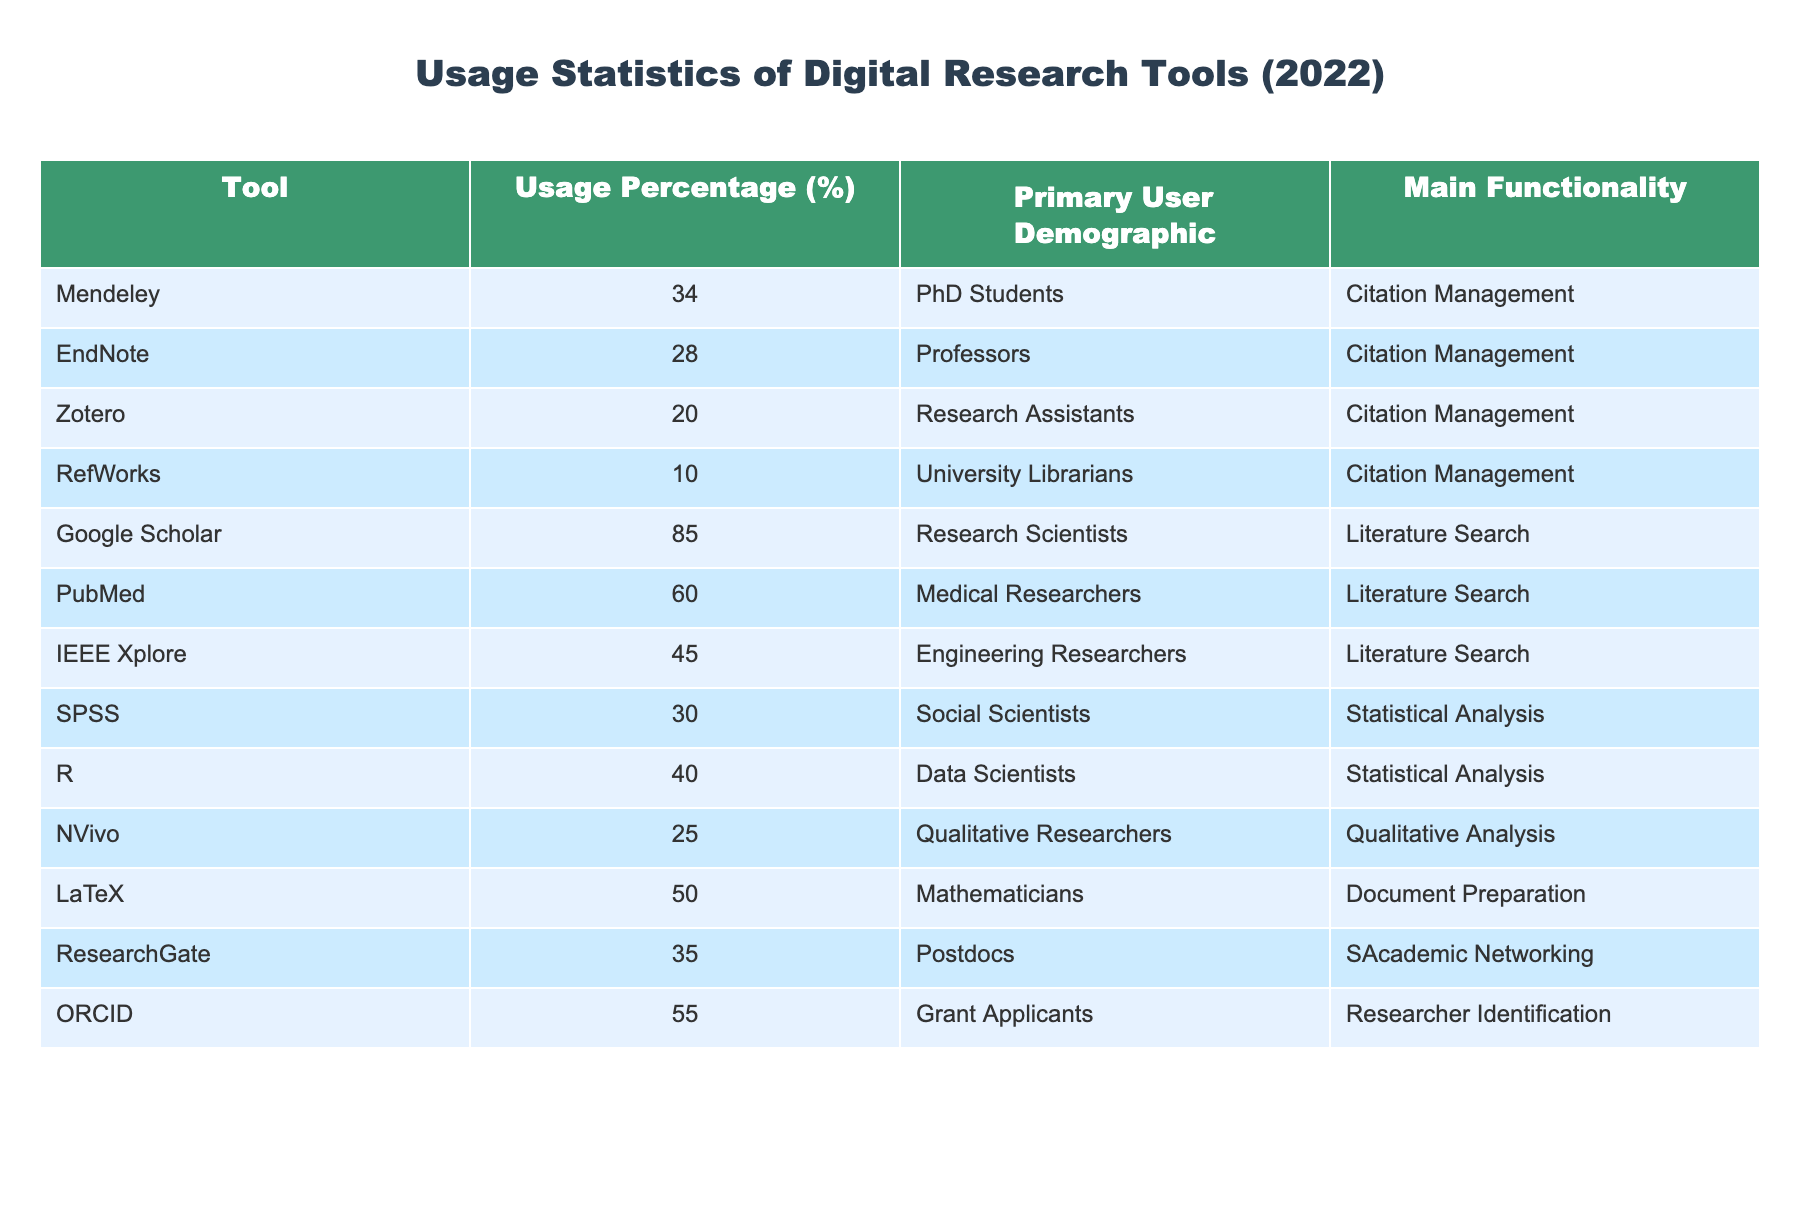What is the usage percentage of Google Scholar among academic researchers? Referring to the table, Google Scholar has a usage percentage of 85%.
Answer: 85% Which tool has the highest usage percentage, and what is its primary user demographic? The tool with the highest usage percentage is Google Scholar at 85%, and its primary user demographic is Research Scientists.
Answer: Google Scholar, Research Scientists What is the combined usage percentage of all citation management tools listed in the table? The citation management tools are Mendeley (34), EndNote (28), Zotero (20), and RefWorks (10). Summing these gives 34 + 28 + 20 + 10 = 92%.
Answer: 92% Is the usage percentage of SPSS greater than that of NVivo? SPSS has a usage percentage of 30%, while NVivo has 25%. Since 30 > 25, the statement is true.
Answer: Yes Which demographic utilizes the highest percentage of tools for literature search, and what tools do they primarily use? Based on the table, Research Scientists utilize Google Scholar (85%), Medical Researchers use PubMed (60%), and Engineering Researchers use IEEE Xplore (45%). The highest percentage is from Google Scholar at 85% by Research Scientists.
Answer: Research Scientists, Google Scholar What tool has a usage percentage close to the average of all listed tools and what is that average percentage? The average percentage is calculated by adding all usage percentages (34 + 28 + 20 + 10 + 85 + 60 + 45 + 30 + 40 + 25 + 50 + 35 + 55 =  420) and dividing by the number of tools (13) yielding an average of approximately 32.31%. Both R (40%) and ORCID (55%) are relatively close to this average.
Answer: R and ORCID, 32.31% Is Zotero primarily used by PhD students according to the table? The table states that Zotero is primarily used by Research Assistants, not PhD students, so this statement is false.
Answer: No What is the difference in usage percentage between the tool with the highest percentage and the lowest usage percentage? Google Scholar has the highest usage percentage at 85%, while RefWorks has the lowest at 10%. The difference is 85 - 10 = 75.
Answer: 75 